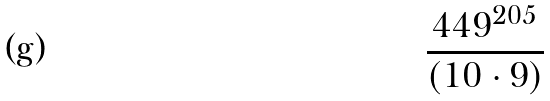Convert formula to latex. <formula><loc_0><loc_0><loc_500><loc_500>\frac { 4 4 9 ^ { 2 0 5 } } { ( 1 0 \cdot 9 ) }</formula> 